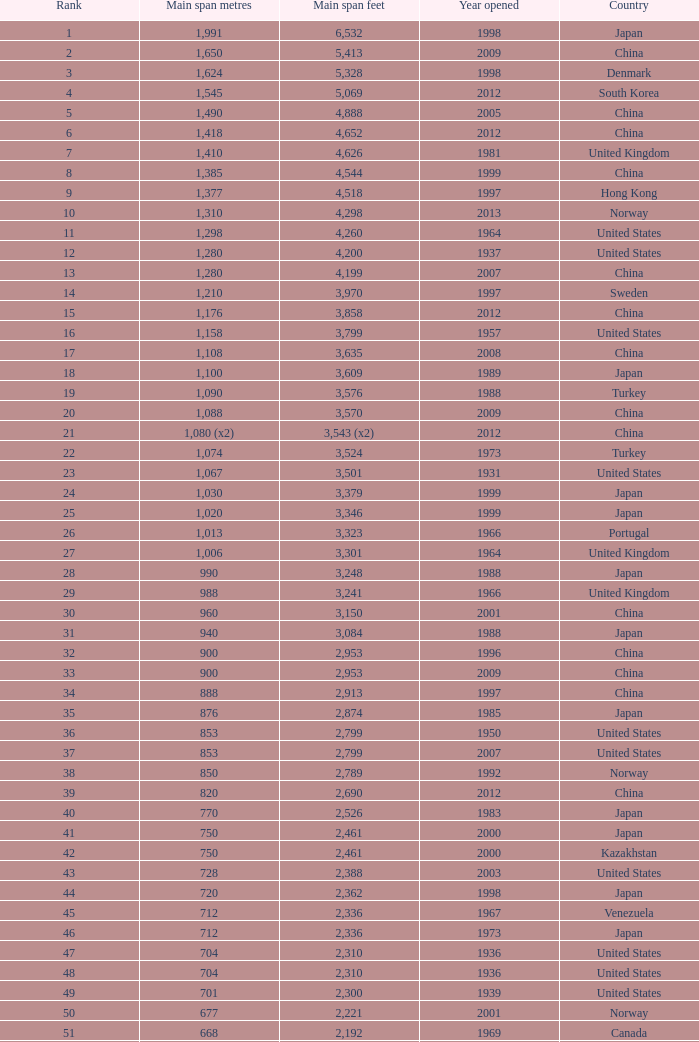What is the principal span in feet from a year of 2009 or more current with a rank lesser than 94 and 1,310 main span meters? 4298.0. 